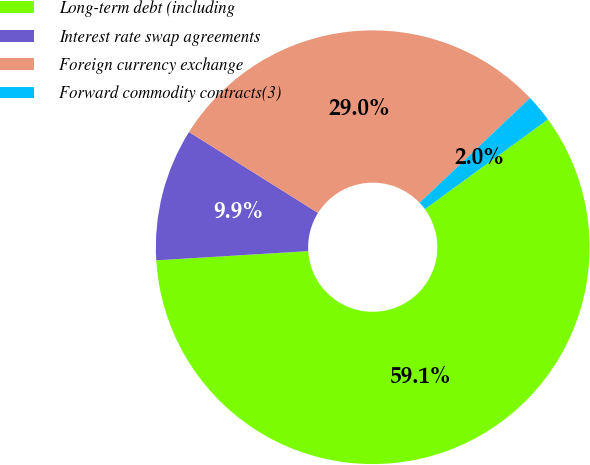Convert chart. <chart><loc_0><loc_0><loc_500><loc_500><pie_chart><fcel>Long-term debt (including<fcel>Interest rate swap agreements<fcel>Foreign currency exchange<fcel>Forward commodity contracts(3)<nl><fcel>59.07%<fcel>9.88%<fcel>29.0%<fcel>2.05%<nl></chart> 